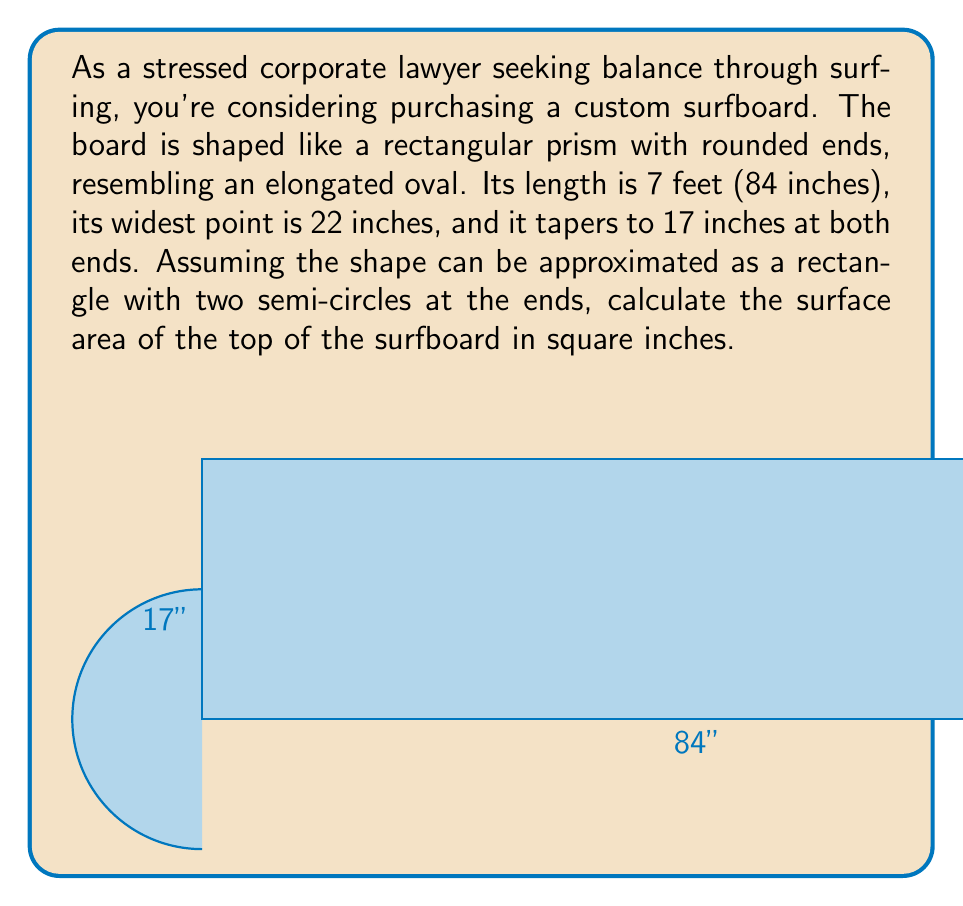What is the answer to this math problem? Let's approach this step-by-step:

1) The surfboard can be divided into three parts: a rectangle in the middle and two semi-circles at the ends.

2) For the rectangle:
   - Length = Total length - Diameter of one circle
   - Length = 84" - 17" = 67"
   - Width = 22"
   - Area of rectangle = $67 \times 22 = 1474$ sq inches

3) For the semi-circles:
   - Diameter = 17"
   - Radius = 17"/2 = 8.5"
   - Area of one full circle = $\pi r^2 = \pi (8.5)^2 = 226.98$ sq inches
   - Area of one semi-circle = 226.98/2 = 113.49 sq inches
   - Area of two semi-circles = $2 \times 113.49 = 226.98$ sq inches

4) Total surface area:
   $$ A_{total} = A_{rectangle} + A_{semi-circles} $$
   $$ A_{total} = 1474 + 226.98 = 1700.98 \text{ sq inches} $$

5) Rounding to the nearest square inch:
   $$ A_{total} \approx 1701 \text{ sq inches} $$

This area represents the top surface of the surfboard, providing a good approximation for the riding surface.
Answer: $$1701 \text{ sq inches}$$ 